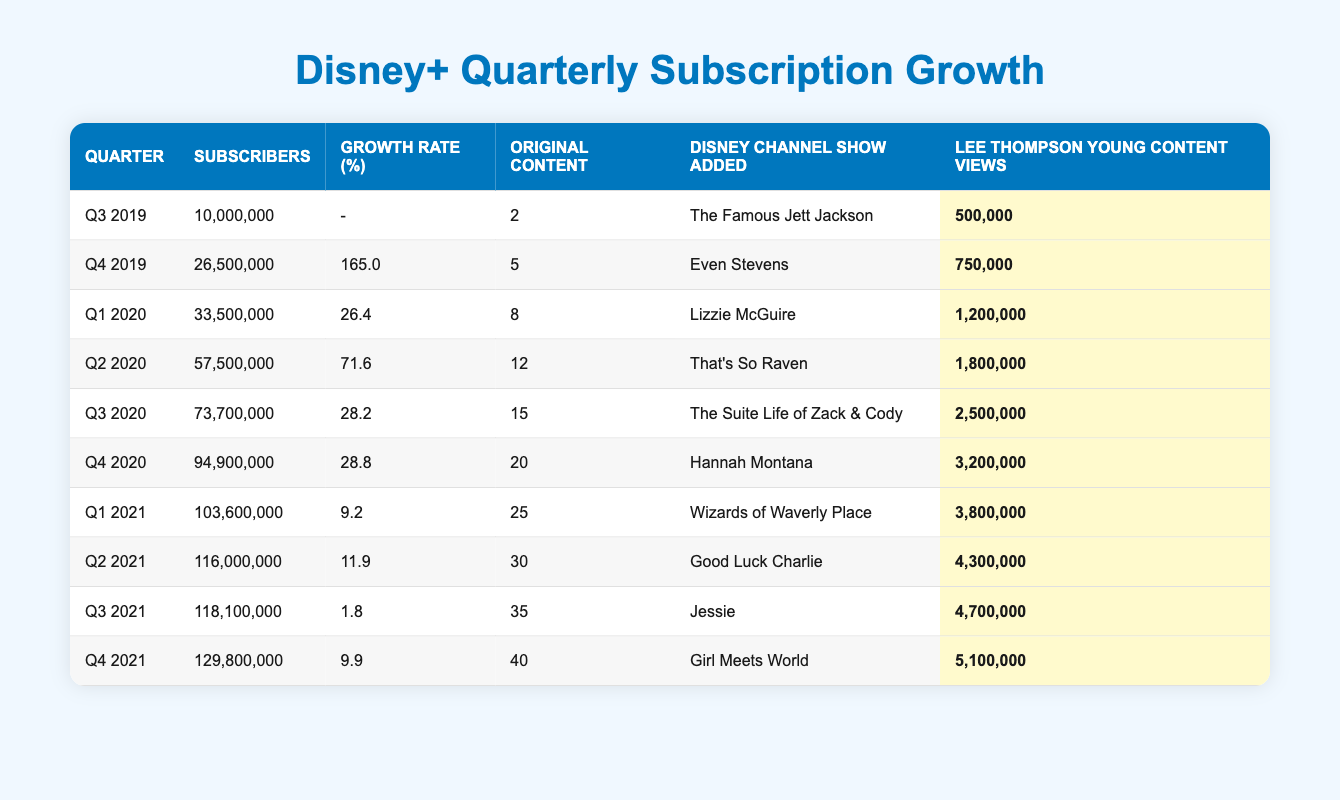What was the subscriber count in Q4 2020? The table shows that the subscriber count in Q4 2020 is listed directly in the respective row for that quarter. The value is 94,900,000.
Answer: 94,900,000 What was the growth rate in Q1 2021? The table indicates the growth rate for Q1 2021 is provided in the corresponding row. The growth rate is 9.2%.
Answer: 9.2% Which Disney Channel show was added in Q3 2021? By referring to the row for Q3 2021, we can see that the Disney Channel show added during that quarter was "Jessie."
Answer: Jessie What is the average number of original content releases over these quarters? To find the average, we sum the number of original content releases: (2 + 5 + 8 + 12 + 15 + 20 + 25 + 30 + 35 + 40) = 192. Then divide by the number of quarters (10), so 192/10 = 19.2.
Answer: 19.2 Is the subscriber total in Q2 2021 greater than 120 million? Checking the subscriber total for Q2 2021, we find it is 116,000,000, which is less than 120 million. Therefore, the answer is false.
Answer: No How many additional subscribers did Disney+ gain from Q1 2021 to Q2 2021? The subscriber count in Q1 2021 is 103,600,000 and in Q2 2021 is 116,000,000. To find the difference, we subtract: 116,000,000 - 103,600,000 = 12,400,000.
Answer: 12,400,000 What was the total number of Lee Thompson Young content views from Q1 2020 to Q4 2020? We sum the views from these quarters: (1,200,000 + 1,800,000 + 2,500,000 + 3,200,000) = 8,700,000 views.
Answer: 8,700,000 Did the growth rate increase from Q3 2020 to Q4 2020? The growth rate for Q3 2020 is 28.2% and for Q4 2020 is 28.8%. Since 28.8% is greater than 28.2%, the growth rate did increase.
Answer: Yes What was the highest number of Lee Thompson Young content views recorded in a quarter? Looking through the table, the highest number is found in Q4 2021 with 5,100,000 views.
Answer: 5,100,000 